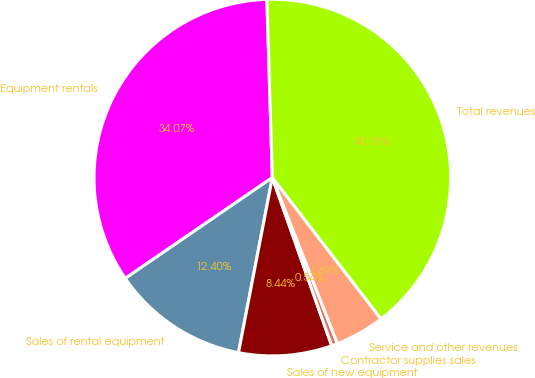<chart> <loc_0><loc_0><loc_500><loc_500><pie_chart><fcel>Equipment rentals<fcel>Sales of rental equipment<fcel>Sales of new equipment<fcel>Contractor supplies sales<fcel>Service and other revenues<fcel>Total revenues<nl><fcel>34.07%<fcel>12.4%<fcel>8.44%<fcel>0.54%<fcel>4.49%<fcel>40.05%<nl></chart> 